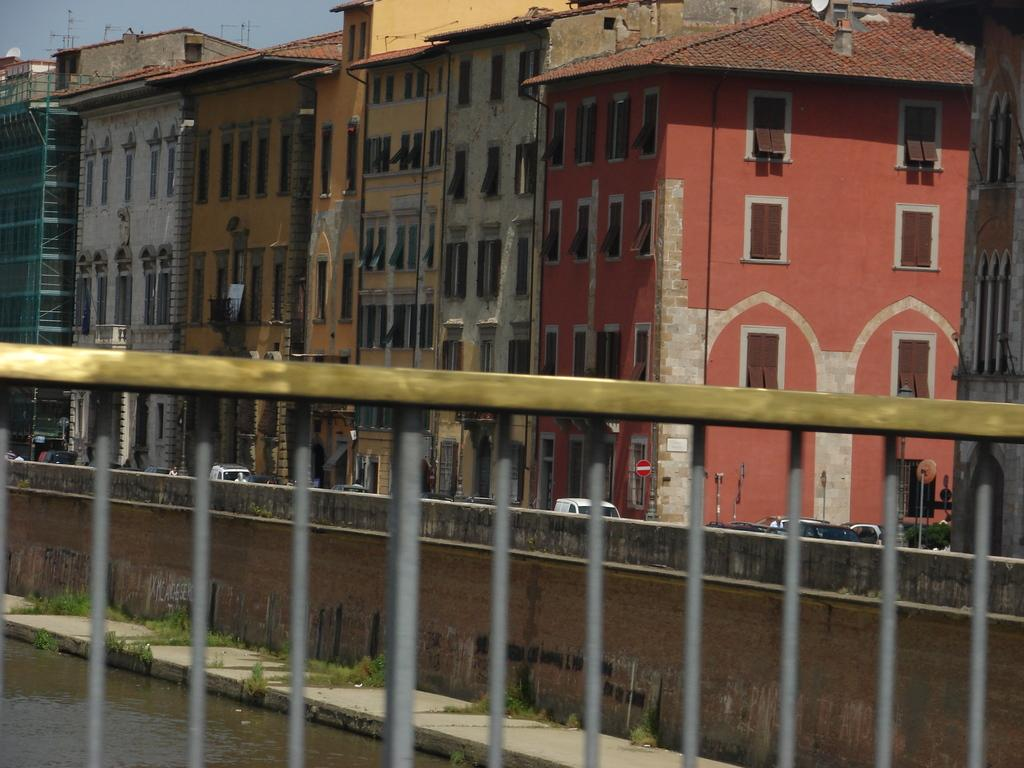What type of barrier is present in the image? There is a fence in the image. What can be seen through the fence? Water and grass are visible through the fence. What is visible in the background of the image? There is a wall, buildings, vehicles, boards on poles, and the sky visible in the background of the image. What type of sound can be heard coming from the fork in the image? There is no fork present in the image, so it is not possible to determine what sound might be heard. 